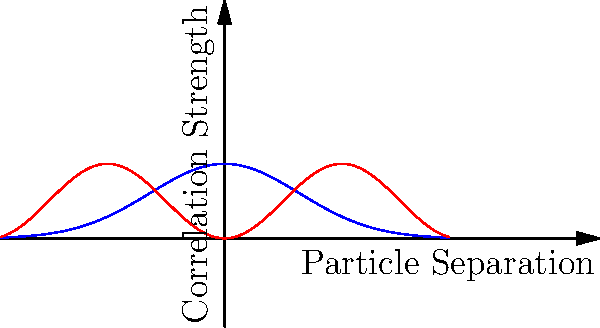In the graph above, which represents quantum correlations in a multi-particle system, what does the blue curve (labeled "Entanglement Measure") suggest about the nature of entanglement as particle separation increases? How does this compare to the red curve (labeled "Quantum Correlation")? To analyze this graph, let's follow these steps:

1. Observe the blue curve (Entanglement Measure):
   - It starts at a maximum at x = 0
   - It decreases rapidly as x (particle separation) increases
   - It approaches zero for large x values

2. Interpret the blue curve:
   - This suggests that entanglement is strongest when particles are close together
   - Entanglement decreases exponentially with distance
   - At large separations, entanglement becomes negligible

3. Observe the red curve (Quantum Correlation):
   - It oscillates between 0 and 1
   - The amplitude remains constant regardless of x

4. Interpret the red curve:
   - This represents quantum correlations that persist even at large separations
   - These correlations don't decay with distance but oscillate periodically

5. Compare the two curves:
   - Entanglement (blue) is a stronger form of quantum correlation that decays with distance
   - Quantum correlations (red) can persist even when entanglement has decayed to negligible levels

6. Scientific implications:
   - This graph illustrates the concept of "entanglement sudden death" vs. persistent quantum correlations
   - It suggests that some quantum effects can survive even when strong entanglement is lost

The key takeaway is that while entanglement (a strong form of quantum correlation) decays rapidly with particle separation, other forms of quantum correlations can persist over longer distances.
Answer: Entanglement decays exponentially with particle separation, while other quantum correlations persist and oscillate. 